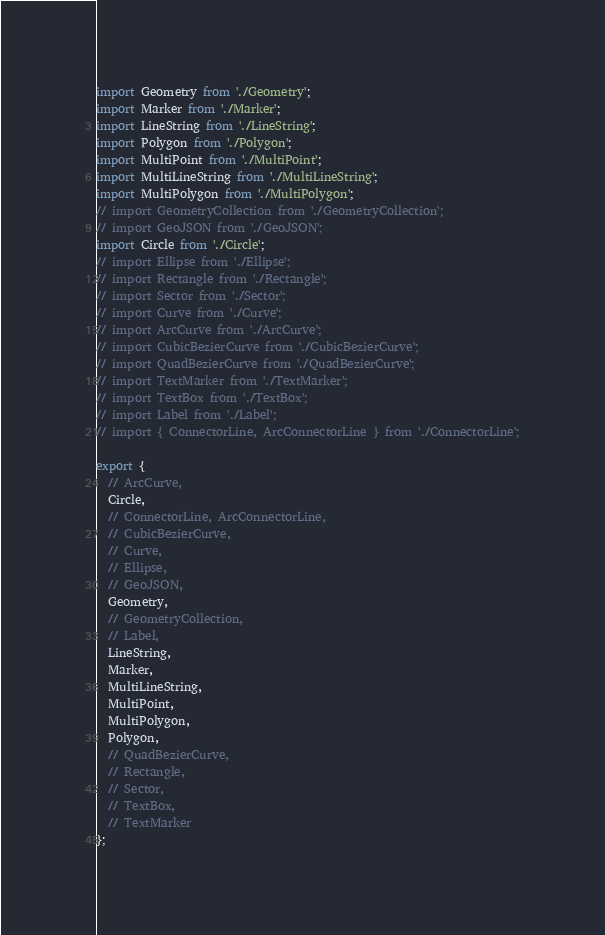Convert code to text. <code><loc_0><loc_0><loc_500><loc_500><_JavaScript_>import Geometry from './Geometry';
import Marker from './Marker';
import LineString from './LineString';
import Polygon from './Polygon';
import MultiPoint from './MultiPoint';
import MultiLineString from './MultiLineString';
import MultiPolygon from './MultiPolygon';
// import GeometryCollection from './GeometryCollection';
// import GeoJSON from './GeoJSON';
import Circle from './Circle';
// import Ellipse from './Ellipse';
// import Rectangle from './Rectangle';
// import Sector from './Sector';
// import Curve from './Curve';
// import ArcCurve from './ArcCurve';
// import CubicBezierCurve from './CubicBezierCurve';
// import QuadBezierCurve from './QuadBezierCurve';
// import TextMarker from './TextMarker';
// import TextBox from './TextBox';
// import Label from './Label';
// import { ConnectorLine, ArcConnectorLine } from './ConnectorLine';

export {
  // ArcCurve,
  Circle,
  // ConnectorLine, ArcConnectorLine,
  // CubicBezierCurve,
  // Curve,
  // Ellipse,
  // GeoJSON,
  Geometry,
  // GeometryCollection,
  // Label,
  LineString,
  Marker,
  MultiLineString,
  MultiPoint,
  MultiPolygon,
  Polygon,
  // QuadBezierCurve,
  // Rectangle,
  // Sector,
  // TextBox,
  // TextMarker
};
</code> 